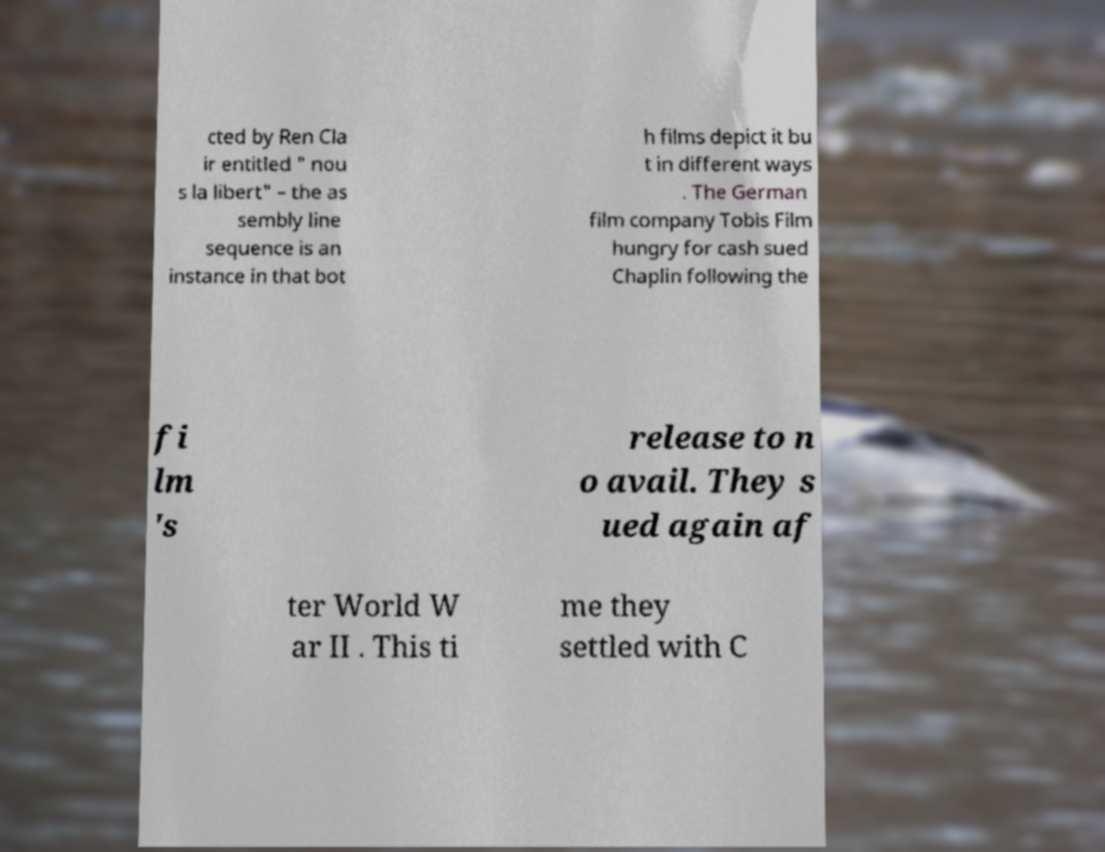Can you accurately transcribe the text from the provided image for me? cted by Ren Cla ir entitled " nou s la libert" – the as sembly line sequence is an instance in that bot h films depict it bu t in different ways . The German film company Tobis Film hungry for cash sued Chaplin following the fi lm 's release to n o avail. They s ued again af ter World W ar II . This ti me they settled with C 